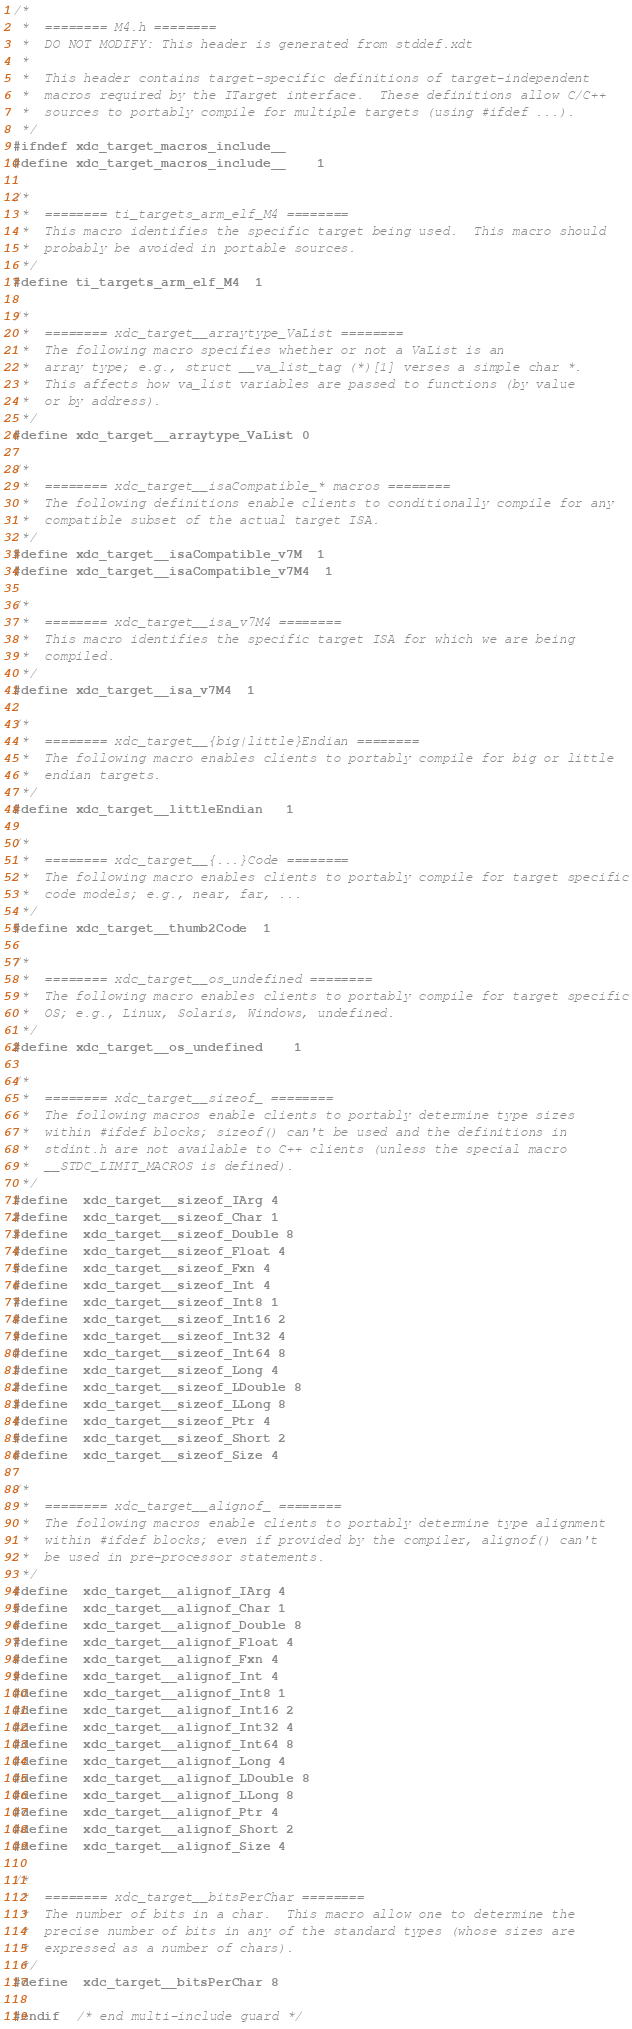<code> <loc_0><loc_0><loc_500><loc_500><_C_>/*
 *  ======== M4.h ========
 *  DO NOT MODIFY: This header is generated from stddef.xdt
 *
 *  This header contains target-specific definitions of target-independent
 *  macros required by the ITarget interface.  These definitions allow C/C++
 *  sources to portably compile for multiple targets (using #ifdef ...).
 */
#ifndef xdc_target_macros_include__
#define xdc_target_macros_include__    1

/*
 *  ======== ti_targets_arm_elf_M4 ========
 *  This macro identifies the specific target being used.  This macro should
 *  probably be avoided in portable sources.
 */
#define ti_targets_arm_elf_M4  1

/*
 *  ======== xdc_target__arraytype_VaList ========
 *  The following macro specifies whether or not a VaList is an 
 *  array type; e.g., struct __va_list_tag (*)[1] verses a simple char *.  
 *  This affects how va_list variables are passed to functions (by value
 *  or by address).
 */
#define xdc_target__arraytype_VaList 0

/*
 *  ======== xdc_target__isaCompatible_* macros ========
 *  The following definitions enable clients to conditionally compile for any
 *  compatible subset of the actual target ISA.
 */
#define xdc_target__isaCompatible_v7M  1
#define xdc_target__isaCompatible_v7M4  1

/*
 *  ======== xdc_target__isa_v7M4 ========
 *  This macro identifies the specific target ISA for which we are being
 *  compiled.
 */
#define xdc_target__isa_v7M4  1

/*
 *  ======== xdc_target__{big|little}Endian ========
 *  The following macro enables clients to portably compile for big or little
 *  endian targets.
 */
#define xdc_target__littleEndian   1

/*
 *  ======== xdc_target__{...}Code ========
 *  The following macro enables clients to portably compile for target specific
 *  code models; e.g., near, far, ...
 */
#define xdc_target__thumb2Code  1

/*
 *  ======== xdc_target__os_undefined ========
 *  The following macro enables clients to portably compile for target specific
 *  OS; e.g., Linux, Solaris, Windows, undefined.
 */
#define xdc_target__os_undefined    1

/*
 *  ======== xdc_target__sizeof_ ========
 *  The following macros enable clients to portably determine type sizes
 *  within #ifdef blocks; sizeof() can't be used and the definitions in
 *  stdint.h are not available to C++ clients (unless the special macro
 *  __STDC_LIMIT_MACROS is defined).
 */
#define  xdc_target__sizeof_IArg 4
#define  xdc_target__sizeof_Char 1
#define  xdc_target__sizeof_Double 8
#define  xdc_target__sizeof_Float 4
#define  xdc_target__sizeof_Fxn 4
#define  xdc_target__sizeof_Int 4
#define  xdc_target__sizeof_Int8 1
#define  xdc_target__sizeof_Int16 2
#define  xdc_target__sizeof_Int32 4
#define  xdc_target__sizeof_Int64 8
#define  xdc_target__sizeof_Long 4
#define  xdc_target__sizeof_LDouble 8
#define  xdc_target__sizeof_LLong 8
#define  xdc_target__sizeof_Ptr 4
#define  xdc_target__sizeof_Short 2
#define  xdc_target__sizeof_Size 4

/*
 *  ======== xdc_target__alignof_ ========
 *  The following macros enable clients to portably determine type alignment
 *  within #ifdef blocks; even if provided by the compiler, alignof() can't
 *  be used in pre-processor statements.
 */
#define  xdc_target__alignof_IArg 4
#define  xdc_target__alignof_Char 1
#define  xdc_target__alignof_Double 8
#define  xdc_target__alignof_Float 4
#define  xdc_target__alignof_Fxn 4
#define  xdc_target__alignof_Int 4
#define  xdc_target__alignof_Int8 1
#define  xdc_target__alignof_Int16 2
#define  xdc_target__alignof_Int32 4
#define  xdc_target__alignof_Int64 8
#define  xdc_target__alignof_Long 4
#define  xdc_target__alignof_LDouble 8
#define  xdc_target__alignof_LLong 8
#define  xdc_target__alignof_Ptr 4
#define  xdc_target__alignof_Short 2
#define  xdc_target__alignof_Size 4

/*
 *  ======== xdc_target__bitsPerChar ========
 *  The number of bits in a char.  This macro allow one to determine the
 *  precise number of bits in any of the standard types (whose sizes are
 *  expressed as a number of chars).
 */
#define  xdc_target__bitsPerChar 8

#endif  /* end multi-include guard */
</code> 